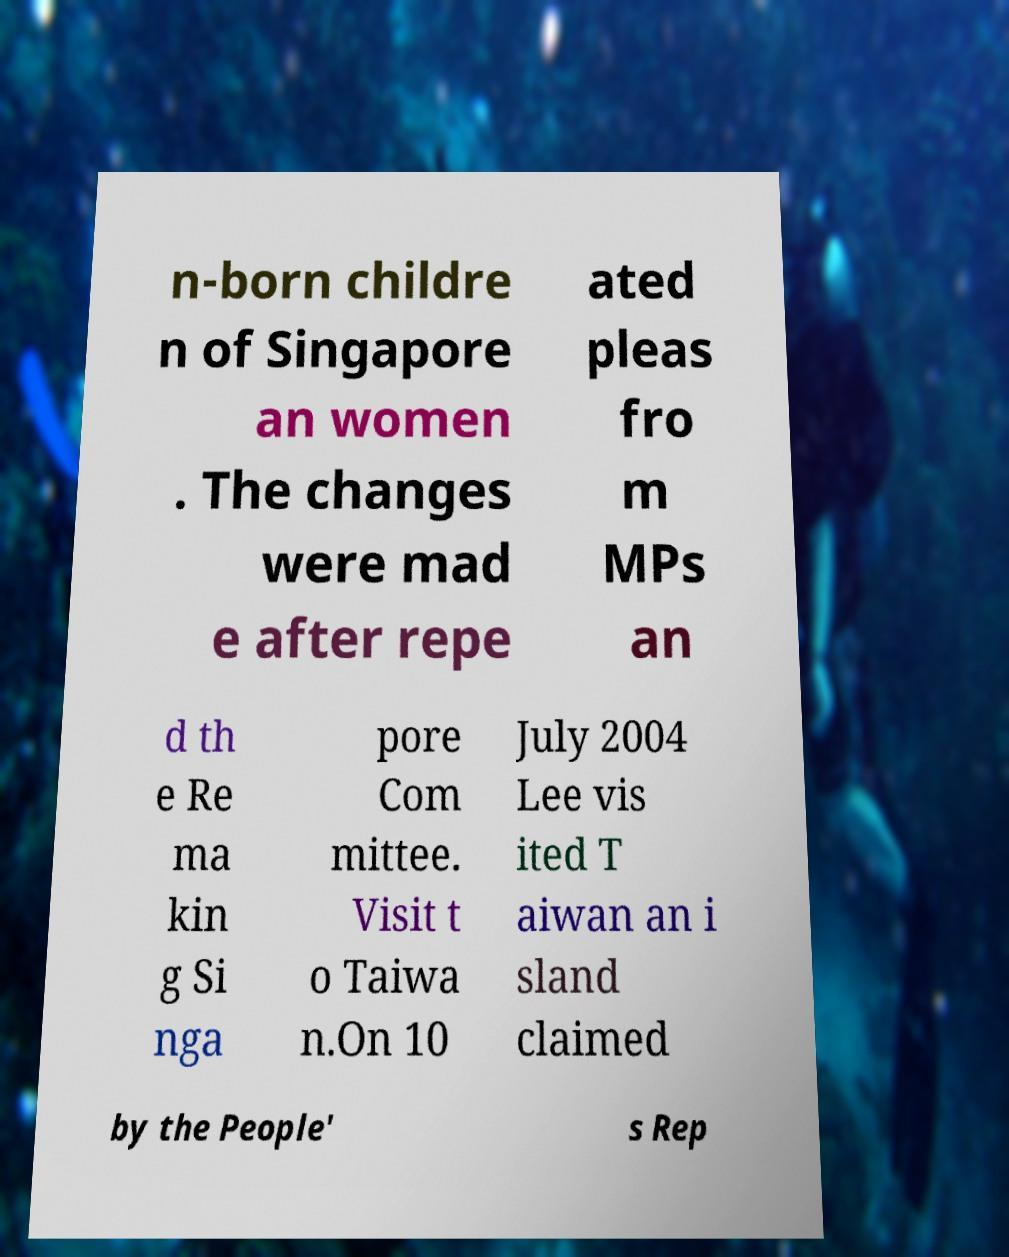Please identify and transcribe the text found in this image. n-born childre n of Singapore an women . The changes were mad e after repe ated pleas fro m MPs an d th e Re ma kin g Si nga pore Com mittee. Visit t o Taiwa n.On 10 July 2004 Lee vis ited T aiwan an i sland claimed by the People' s Rep 